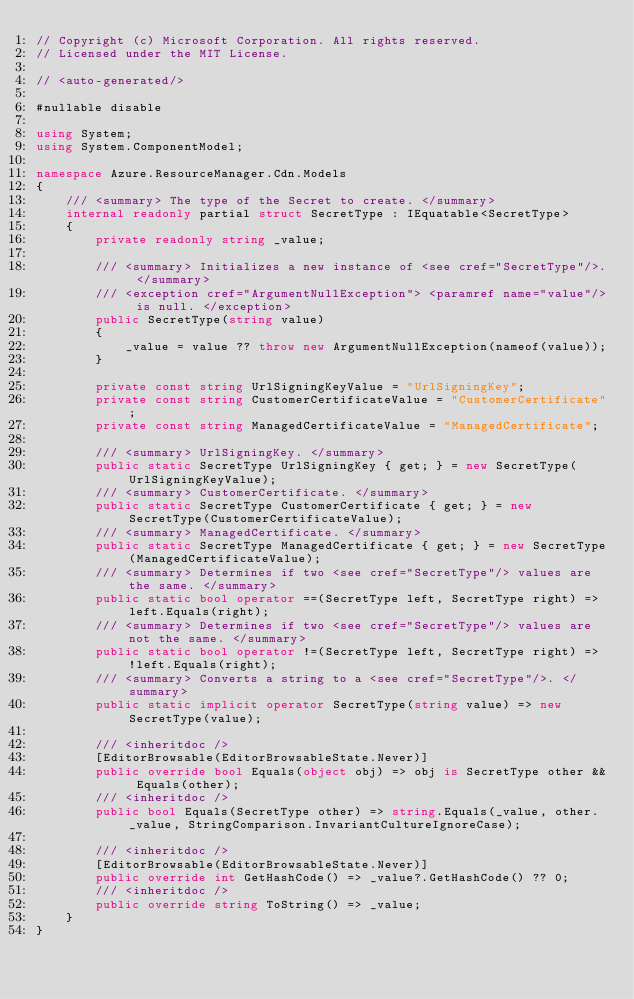<code> <loc_0><loc_0><loc_500><loc_500><_C#_>// Copyright (c) Microsoft Corporation. All rights reserved.
// Licensed under the MIT License.

// <auto-generated/>

#nullable disable

using System;
using System.ComponentModel;

namespace Azure.ResourceManager.Cdn.Models
{
    /// <summary> The type of the Secret to create. </summary>
    internal readonly partial struct SecretType : IEquatable<SecretType>
    {
        private readonly string _value;

        /// <summary> Initializes a new instance of <see cref="SecretType"/>. </summary>
        /// <exception cref="ArgumentNullException"> <paramref name="value"/> is null. </exception>
        public SecretType(string value)
        {
            _value = value ?? throw new ArgumentNullException(nameof(value));
        }

        private const string UrlSigningKeyValue = "UrlSigningKey";
        private const string CustomerCertificateValue = "CustomerCertificate";
        private const string ManagedCertificateValue = "ManagedCertificate";

        /// <summary> UrlSigningKey. </summary>
        public static SecretType UrlSigningKey { get; } = new SecretType(UrlSigningKeyValue);
        /// <summary> CustomerCertificate. </summary>
        public static SecretType CustomerCertificate { get; } = new SecretType(CustomerCertificateValue);
        /// <summary> ManagedCertificate. </summary>
        public static SecretType ManagedCertificate { get; } = new SecretType(ManagedCertificateValue);
        /// <summary> Determines if two <see cref="SecretType"/> values are the same. </summary>
        public static bool operator ==(SecretType left, SecretType right) => left.Equals(right);
        /// <summary> Determines if two <see cref="SecretType"/> values are not the same. </summary>
        public static bool operator !=(SecretType left, SecretType right) => !left.Equals(right);
        /// <summary> Converts a string to a <see cref="SecretType"/>. </summary>
        public static implicit operator SecretType(string value) => new SecretType(value);

        /// <inheritdoc />
        [EditorBrowsable(EditorBrowsableState.Never)]
        public override bool Equals(object obj) => obj is SecretType other && Equals(other);
        /// <inheritdoc />
        public bool Equals(SecretType other) => string.Equals(_value, other._value, StringComparison.InvariantCultureIgnoreCase);

        /// <inheritdoc />
        [EditorBrowsable(EditorBrowsableState.Never)]
        public override int GetHashCode() => _value?.GetHashCode() ?? 0;
        /// <inheritdoc />
        public override string ToString() => _value;
    }
}
</code> 